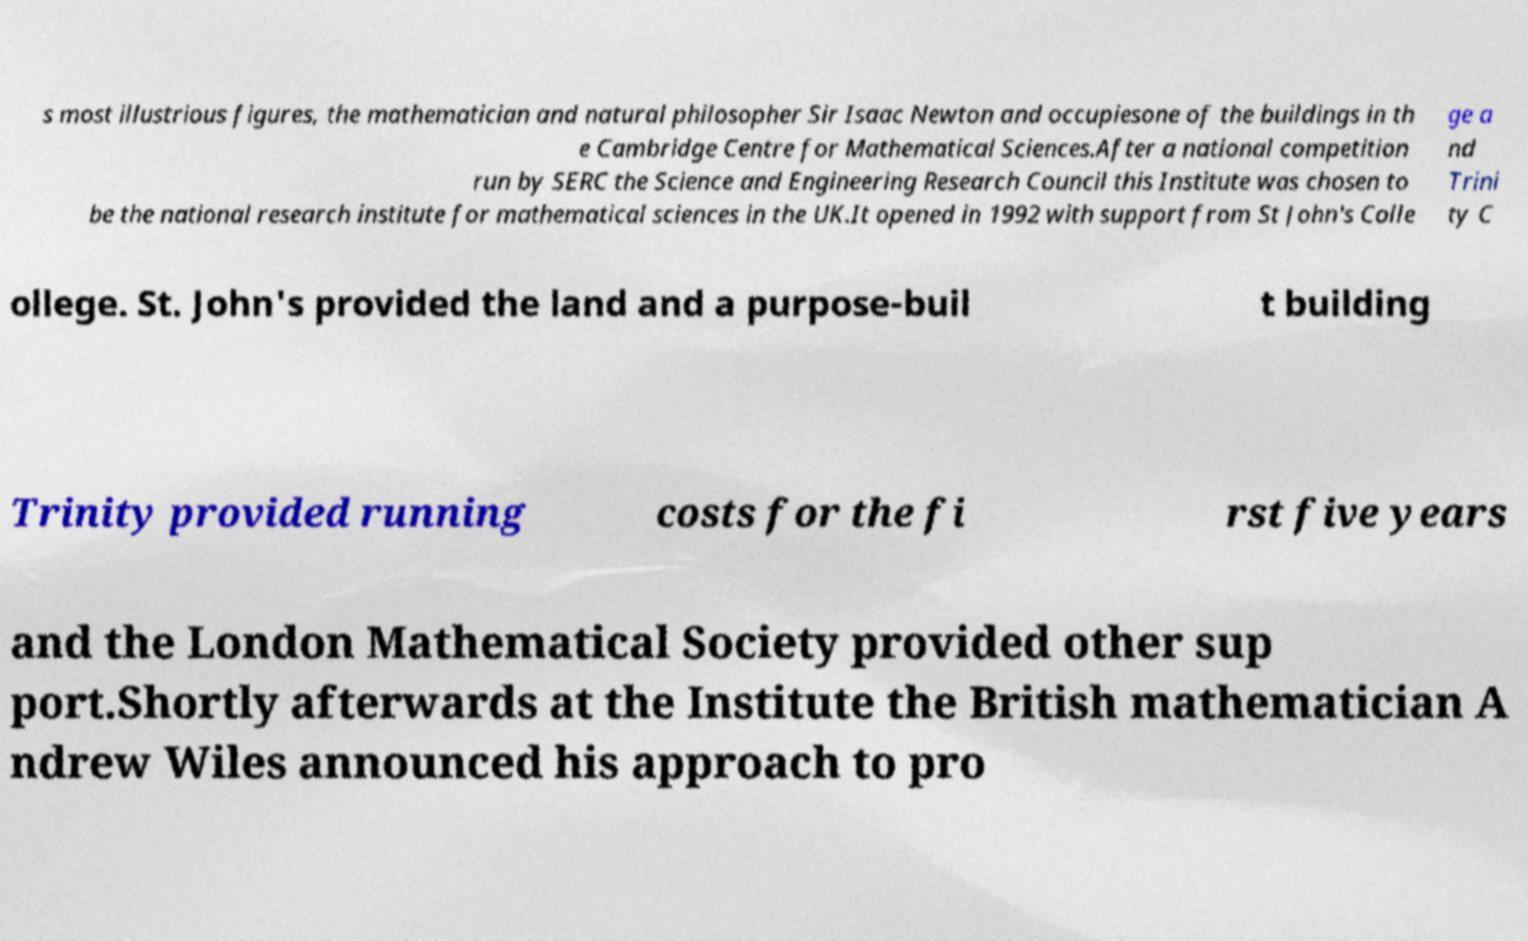For documentation purposes, I need the text within this image transcribed. Could you provide that? s most illustrious figures, the mathematician and natural philosopher Sir Isaac Newton and occupiesone of the buildings in th e Cambridge Centre for Mathematical Sciences.After a national competition run by SERC the Science and Engineering Research Council this Institute was chosen to be the national research institute for mathematical sciences in the UK.It opened in 1992 with support from St John's Colle ge a nd Trini ty C ollege. St. John's provided the land and a purpose-buil t building Trinity provided running costs for the fi rst five years and the London Mathematical Society provided other sup port.Shortly afterwards at the Institute the British mathematician A ndrew Wiles announced his approach to pro 